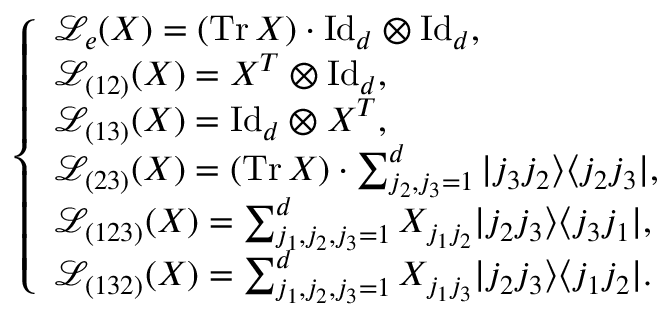Convert formula to latex. <formula><loc_0><loc_0><loc_500><loc_500>\left \{ \begin{array} { l l l l l l l } { \mathcal { L } _ { e } ( X ) = ( T r \, X ) \cdot I d _ { d } \otimes I d _ { d } , } \\ { \mathcal { L } _ { ( 1 2 ) } ( X ) = X ^ { T } \otimes I d _ { d } , } \\ { \mathcal { L } _ { ( 1 3 ) } ( X ) = I d _ { d } \otimes X ^ { T } , } \\ { \mathcal { L } _ { ( 2 3 ) } ( X ) = ( T r \, X ) \cdot \sum _ { j _ { 2 } , j _ { 3 } = 1 } ^ { d } | j _ { 3 } j _ { 2 } \rangle \langle j _ { 2 } j _ { 3 } | , } \\ { \mathcal { L } _ { ( 1 2 3 ) } ( X ) = \sum _ { j _ { 1 } , j _ { 2 } , j _ { 3 } = 1 } ^ { d } X _ { j _ { 1 } j _ { 2 } } | j _ { 2 } j _ { 3 } \rangle \langle j _ { 3 } j _ { 1 } | , } \\ { \mathcal { L } _ { ( 1 3 2 ) } ( X ) = \sum _ { j _ { 1 } , j _ { 2 } , j _ { 3 } = 1 } ^ { d } X _ { j _ { 1 } j _ { 3 } } | j _ { 2 } j _ { 3 } \rangle \langle j _ { 1 } j _ { 2 } | . } \end{array}</formula> 